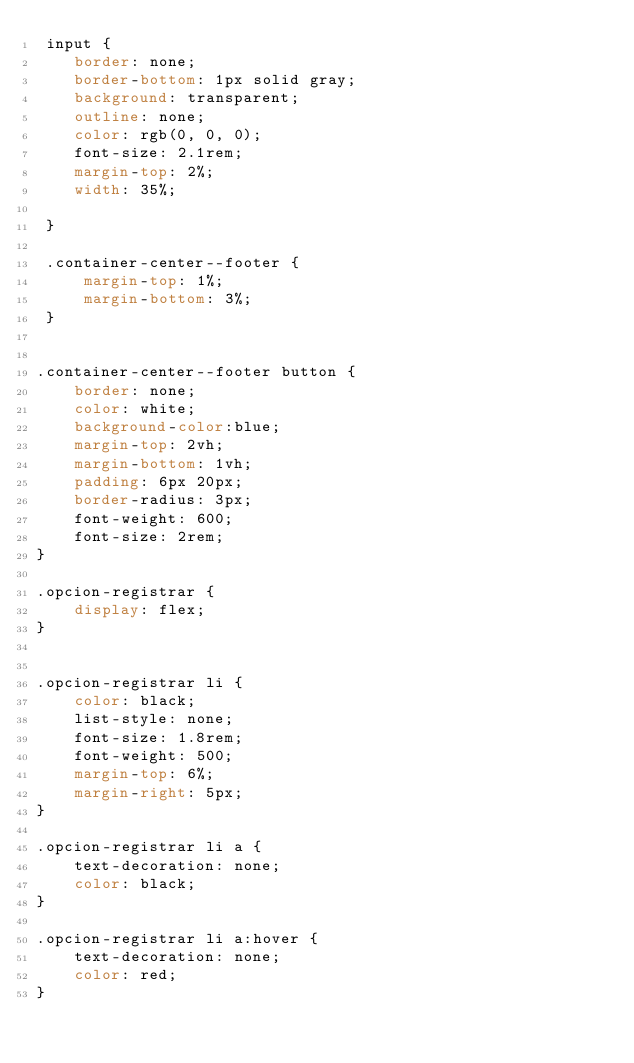Convert code to text. <code><loc_0><loc_0><loc_500><loc_500><_CSS_> input {
    border: none;
    border-bottom: 1px solid gray;
    background: transparent;
    outline: none;  
    color: rgb(0, 0, 0);
    font-size: 2.1rem;
    margin-top: 2%;
    width: 35%;
    
 }

 .container-center--footer {
     margin-top: 1%;
     margin-bottom: 3%;
 }


.container-center--footer button {
    border: none;
    color: white;
    background-color:blue;
    margin-top: 2vh;
    margin-bottom: 1vh;
    padding: 6px 20px;
    border-radius: 3px;
    font-weight: 600;
    font-size: 2rem;
}

.opcion-registrar {
    display: flex;
}


.opcion-registrar li {
    color: black;
    list-style: none;
    font-size: 1.8rem;
    font-weight: 500;
    margin-top: 6%;
    margin-right: 5px;
}

.opcion-registrar li a {
    text-decoration: none;
    color: black;
}

.opcion-registrar li a:hover {
    text-decoration: none;
    color: red;
}</code> 